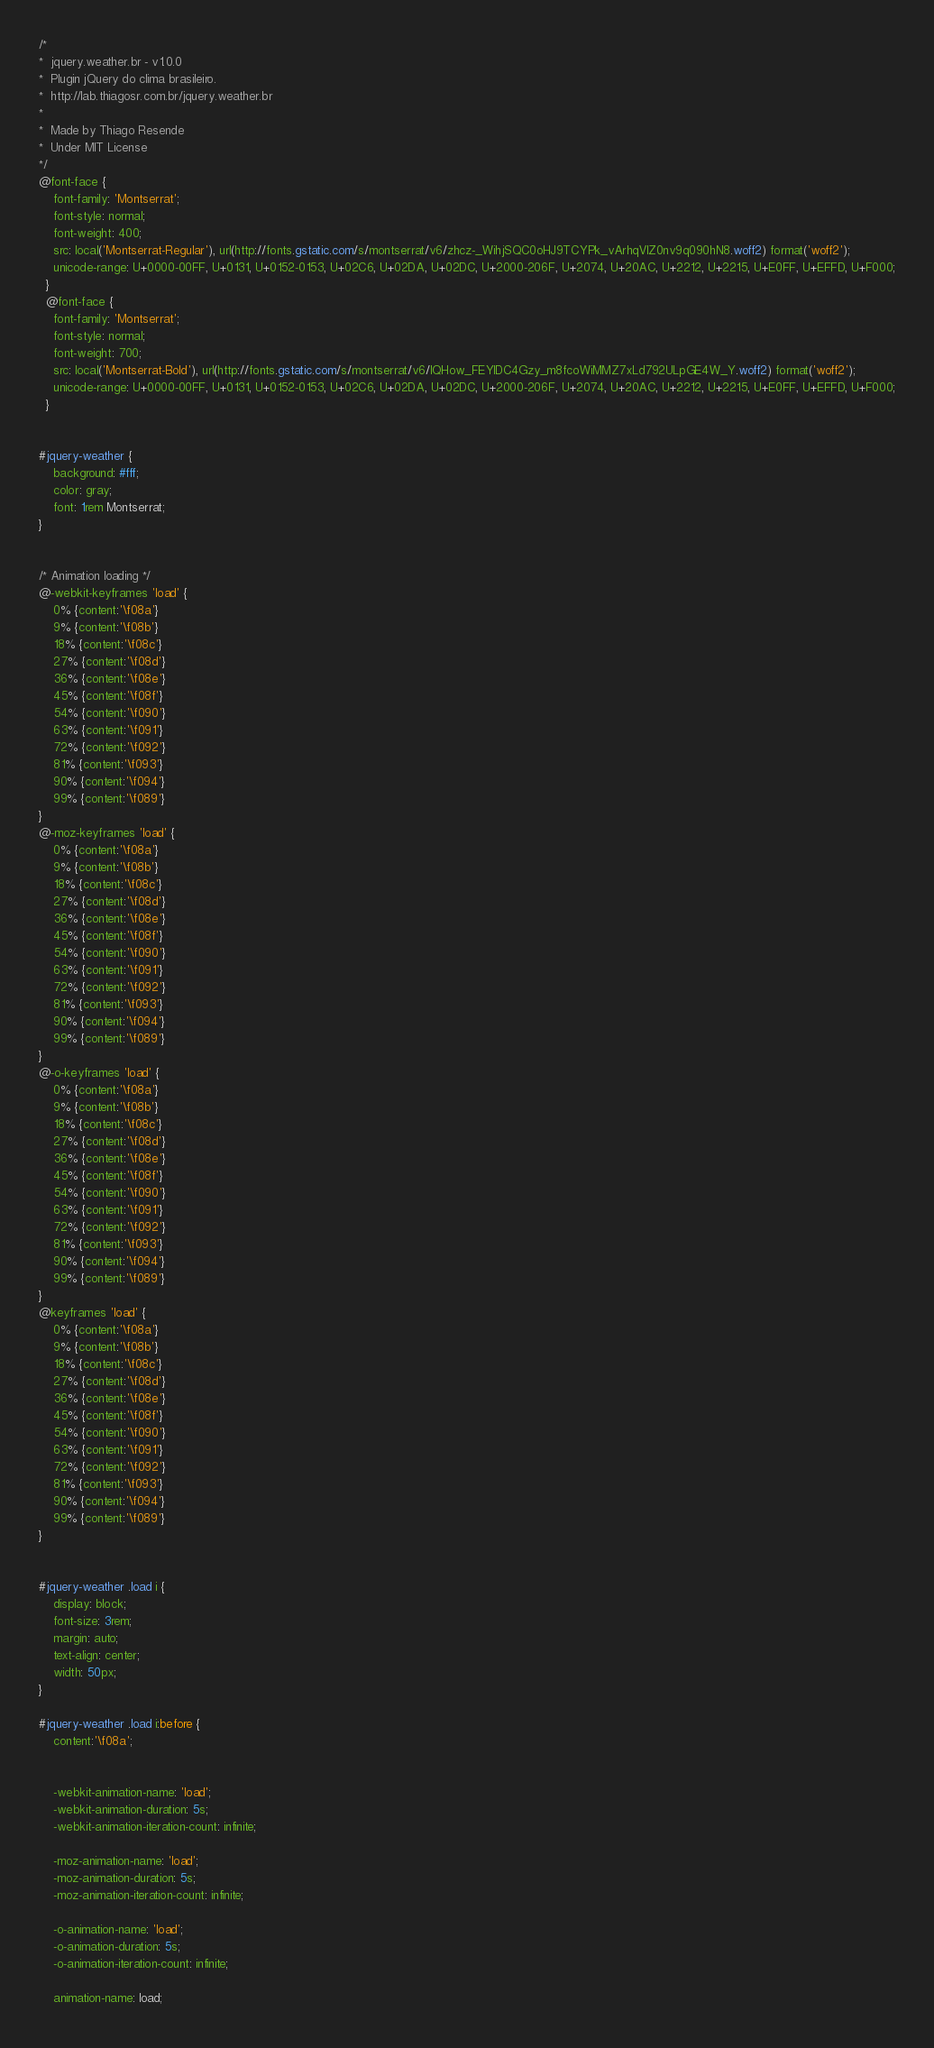<code> <loc_0><loc_0><loc_500><loc_500><_CSS_>/*
*  jquery.weather.br - v1.0.0
*  Plugin jQuery do clima brasileiro.
*  http://lab.thiagosr.com.br/jquery.weather.br
*
*  Made by Thiago Resende
*  Under MIT License
*/
@font-face {
    font-family: 'Montserrat';
    font-style: normal;
    font-weight: 400;
    src: local('Montserrat-Regular'), url(http://fonts.gstatic.com/s/montserrat/v6/zhcz-_WihjSQC0oHJ9TCYPk_vArhqVIZ0nv9q090hN8.woff2) format('woff2');
    unicode-range: U+0000-00FF, U+0131, U+0152-0153, U+02C6, U+02DA, U+02DC, U+2000-206F, U+2074, U+20AC, U+2212, U+2215, U+E0FF, U+EFFD, U+F000;
  }
  @font-face {
    font-family: 'Montserrat';
    font-style: normal;
    font-weight: 700;
    src: local('Montserrat-Bold'), url(http://fonts.gstatic.com/s/montserrat/v6/IQHow_FEYlDC4Gzy_m8fcoWiMMZ7xLd792ULpGE4W_Y.woff2) format('woff2');
    unicode-range: U+0000-00FF, U+0131, U+0152-0153, U+02C6, U+02DA, U+02DC, U+2000-206F, U+2074, U+20AC, U+2212, U+2215, U+E0FF, U+EFFD, U+F000;
  }


#jquery-weather {
    background: #fff;
    color: gray;
    font: 1rem Montserrat;
}


/* Animation loading */
@-webkit-keyframes 'load' {
    0% {content:'\f08a'}
    9% {content:'\f08b'}
    18% {content:'\f08c'}
    27% {content:'\f08d'}
    36% {content:'\f08e'}
    45% {content:'\f08f'}
    54% {content:'\f090'}
    63% {content:'\f091'}
    72% {content:'\f092'}
    81% {content:'\f093'}
    90% {content:'\f094'}
    99% {content:'\f089'}
}
@-moz-keyframes 'load' {
    0% {content:'\f08a'}
    9% {content:'\f08b'}
    18% {content:'\f08c'}
    27% {content:'\f08d'}
    36% {content:'\f08e'}
    45% {content:'\f08f'}
    54% {content:'\f090'}
    63% {content:'\f091'}
    72% {content:'\f092'}
    81% {content:'\f093'}
    90% {content:'\f094'}
    99% {content:'\f089'}
}
@-o-keyframes 'load' {
    0% {content:'\f08a'}
    9% {content:'\f08b'}
    18% {content:'\f08c'}
    27% {content:'\f08d'}
    36% {content:'\f08e'}
    45% {content:'\f08f'}
    54% {content:'\f090'}
    63% {content:'\f091'}
    72% {content:'\f092'}
    81% {content:'\f093'}
    90% {content:'\f094'}
    99% {content:'\f089'}
}
@keyframes 'load' {
    0% {content:'\f08a'}
    9% {content:'\f08b'}
    18% {content:'\f08c'}
    27% {content:'\f08d'}
    36% {content:'\f08e'}
    45% {content:'\f08f'}
    54% {content:'\f090'}
    63% {content:'\f091'}
    72% {content:'\f092'}
    81% {content:'\f093'}
    90% {content:'\f094'}
    99% {content:'\f089'}
}


#jquery-weather .load i {
    display: block;
    font-size: 3rem;
    margin: auto;
    text-align: center;
    width: 50px;
}

#jquery-weather .load i:before {
    content:'\f08a';

    
    -webkit-animation-name: 'load';
    -webkit-animation-duration: 5s;
    -webkit-animation-iteration-count: infinite;

    -moz-animation-name: 'load';
    -moz-animation-duration: 5s;
    -moz-animation-iteration-count: infinite;

    -o-animation-name: 'load';
    -o-animation-duration: 5s;
    -o-animation-iteration-count: infinite;

    animation-name: load;</code> 